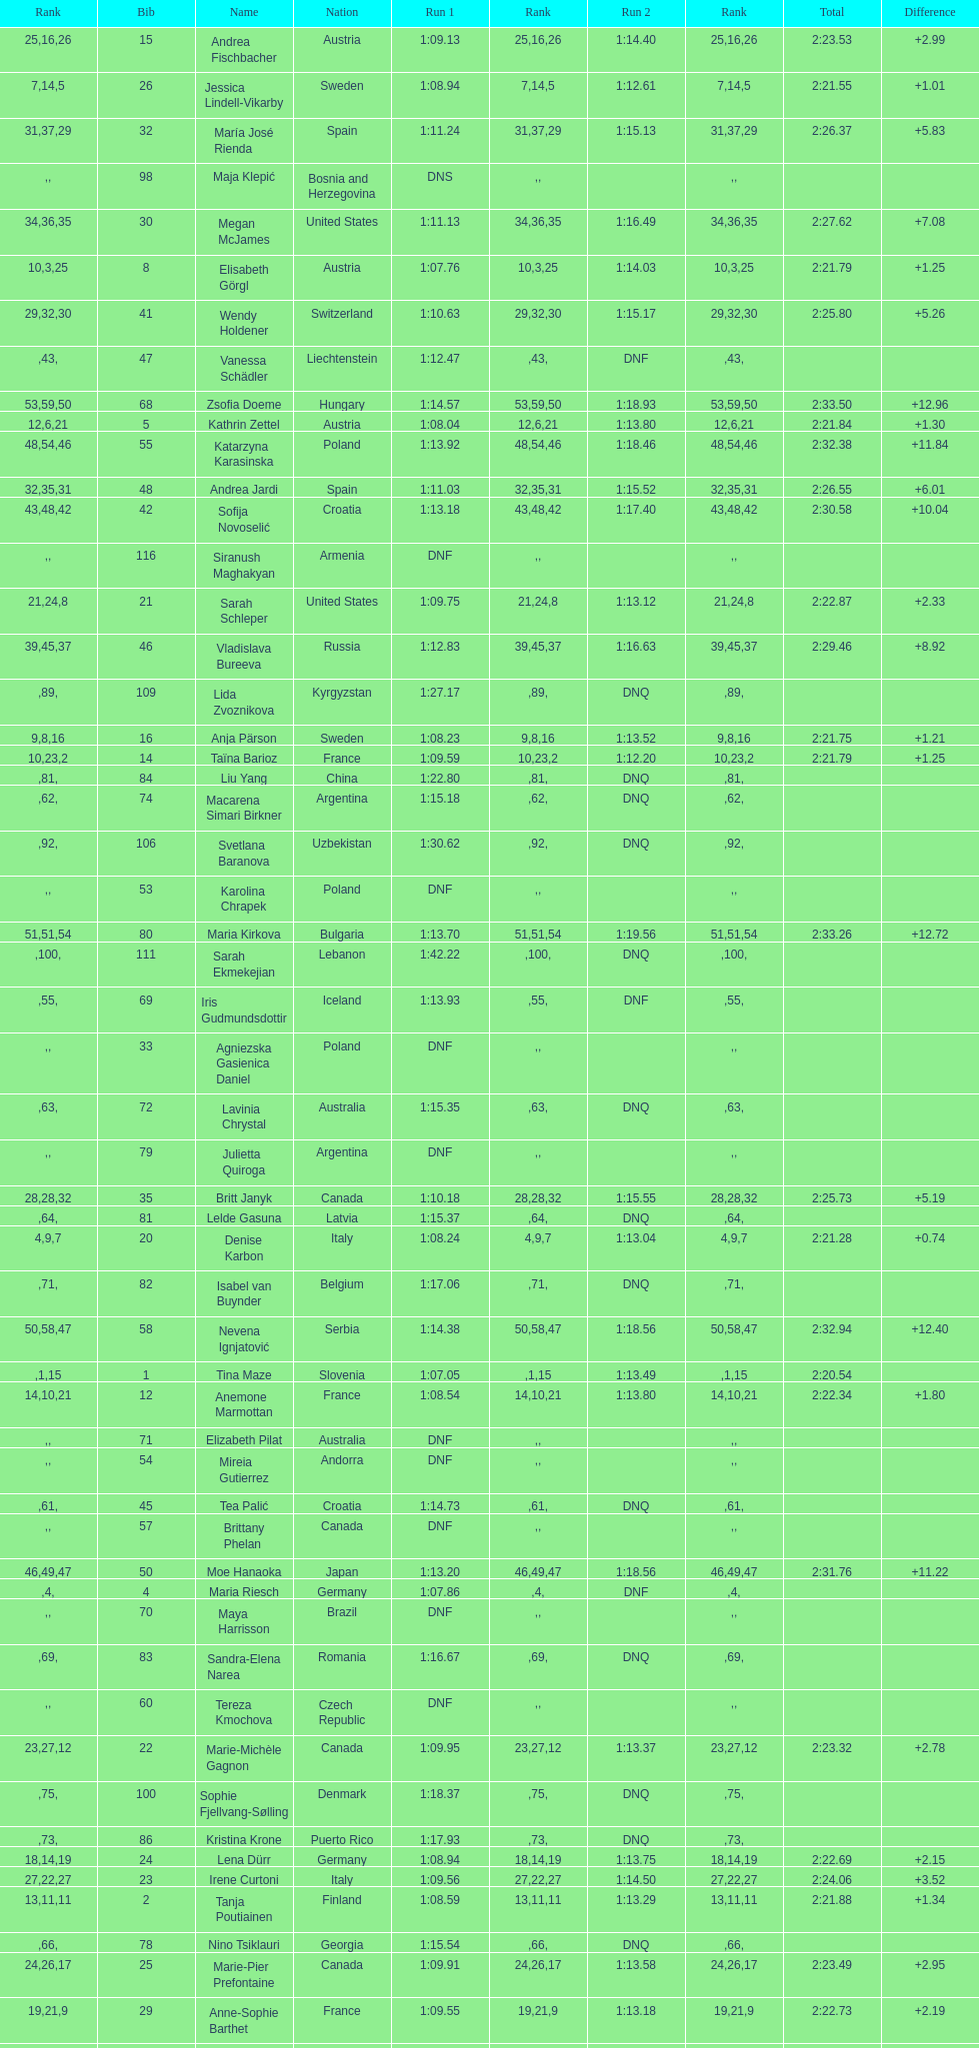Who ranked next after federica brignone? Tessa Worley. 